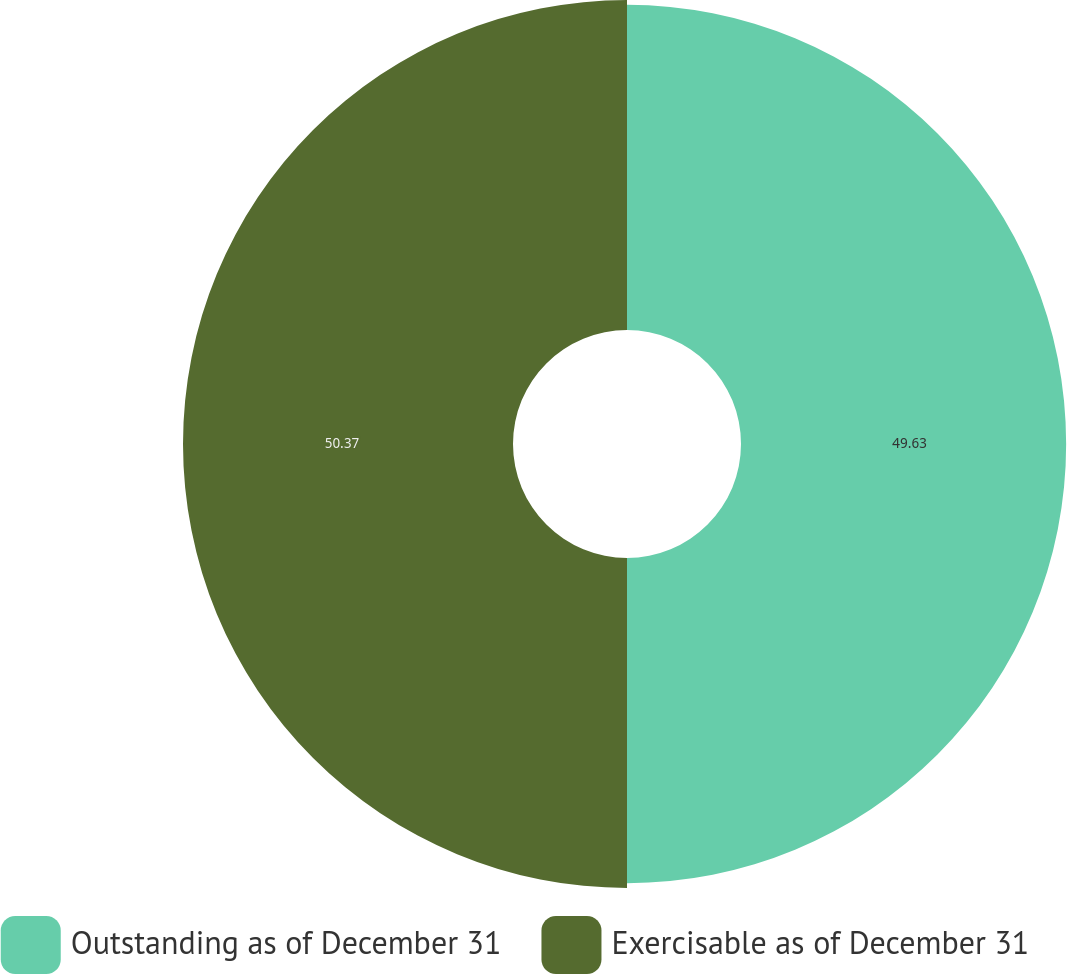Convert chart. <chart><loc_0><loc_0><loc_500><loc_500><pie_chart><fcel>Outstanding as of December 31<fcel>Exercisable as of December 31<nl><fcel>49.63%<fcel>50.37%<nl></chart> 